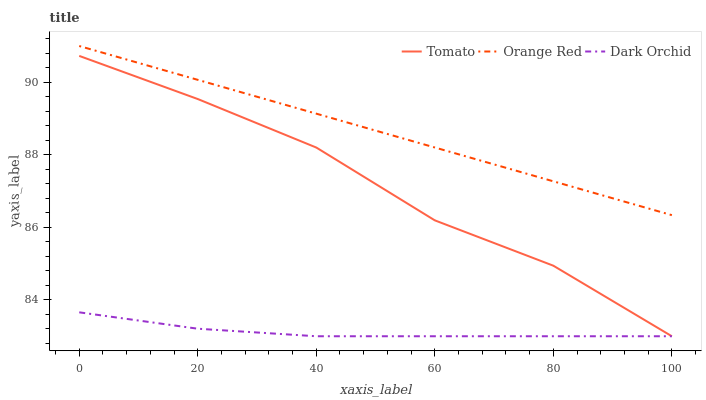Does Dark Orchid have the minimum area under the curve?
Answer yes or no. Yes. Does Orange Red have the maximum area under the curve?
Answer yes or no. Yes. Does Orange Red have the minimum area under the curve?
Answer yes or no. No. Does Dark Orchid have the maximum area under the curve?
Answer yes or no. No. Is Orange Red the smoothest?
Answer yes or no. Yes. Is Tomato the roughest?
Answer yes or no. Yes. Is Dark Orchid the smoothest?
Answer yes or no. No. Is Dark Orchid the roughest?
Answer yes or no. No. Does Tomato have the lowest value?
Answer yes or no. Yes. Does Orange Red have the lowest value?
Answer yes or no. No. Does Orange Red have the highest value?
Answer yes or no. Yes. Does Dark Orchid have the highest value?
Answer yes or no. No. Is Dark Orchid less than Orange Red?
Answer yes or no. Yes. Is Orange Red greater than Dark Orchid?
Answer yes or no. Yes. Does Dark Orchid intersect Tomato?
Answer yes or no. Yes. Is Dark Orchid less than Tomato?
Answer yes or no. No. Is Dark Orchid greater than Tomato?
Answer yes or no. No. Does Dark Orchid intersect Orange Red?
Answer yes or no. No. 